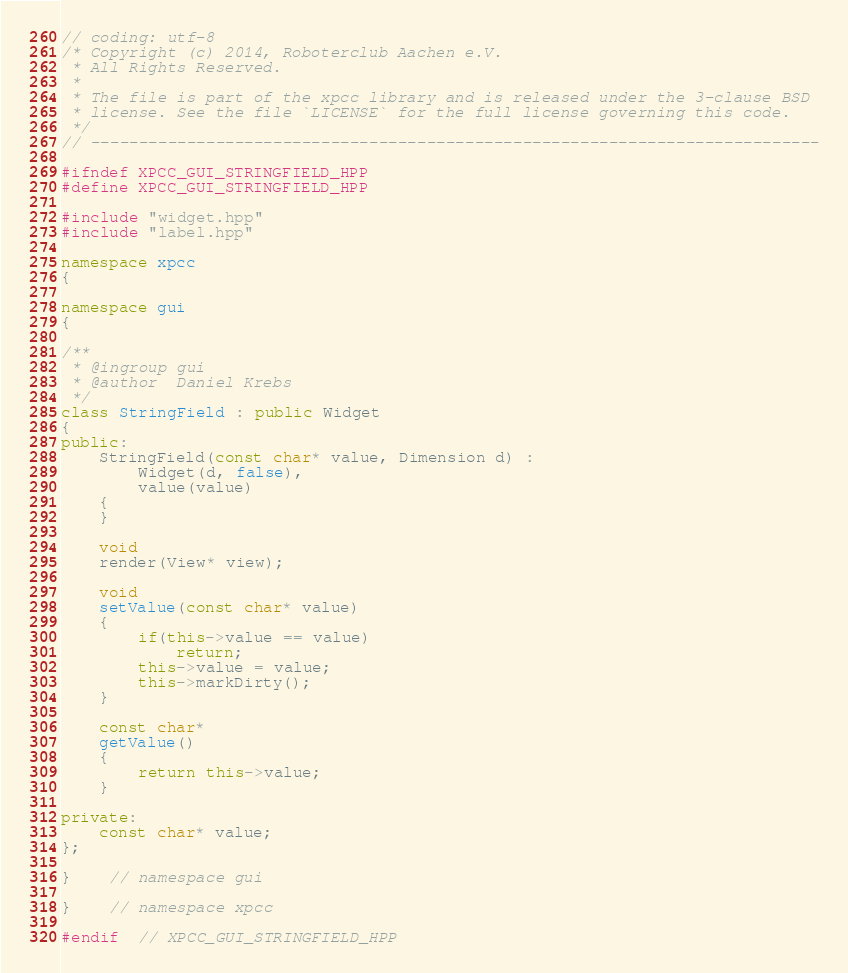Convert code to text. <code><loc_0><loc_0><loc_500><loc_500><_C++_>// coding: utf-8
/* Copyright (c) 2014, Roboterclub Aachen e.V.
 * All Rights Reserved.
 *
 * The file is part of the xpcc library and is released under the 3-clause BSD
 * license. See the file `LICENSE` for the full license governing this code.
 */
// ----------------------------------------------------------------------------

#ifndef XPCC_GUI_STRINGFIELD_HPP
#define XPCC_GUI_STRINGFIELD_HPP

#include "widget.hpp"
#include "label.hpp"

namespace xpcc
{

namespace gui
{

/**
 * @ingroup	gui
 * @author	Daniel Krebs
 */
class StringField : public Widget
{
public:
	StringField(const char* value, Dimension d) :
		Widget(d, false),
		value(value)
	{
	}

	void
	render(View* view);

	void
	setValue(const char* value)
	{
		if(this->value == value)
			return;
		this->value = value;
		this->markDirty();
	}

	const char*
	getValue()
	{
		return this->value;
	}

private:
	const char* value;
};

}	// namespace gui

}	// namespace xpcc

#endif  // XPCC_GUI_STRINGFIELD_HPP
</code> 